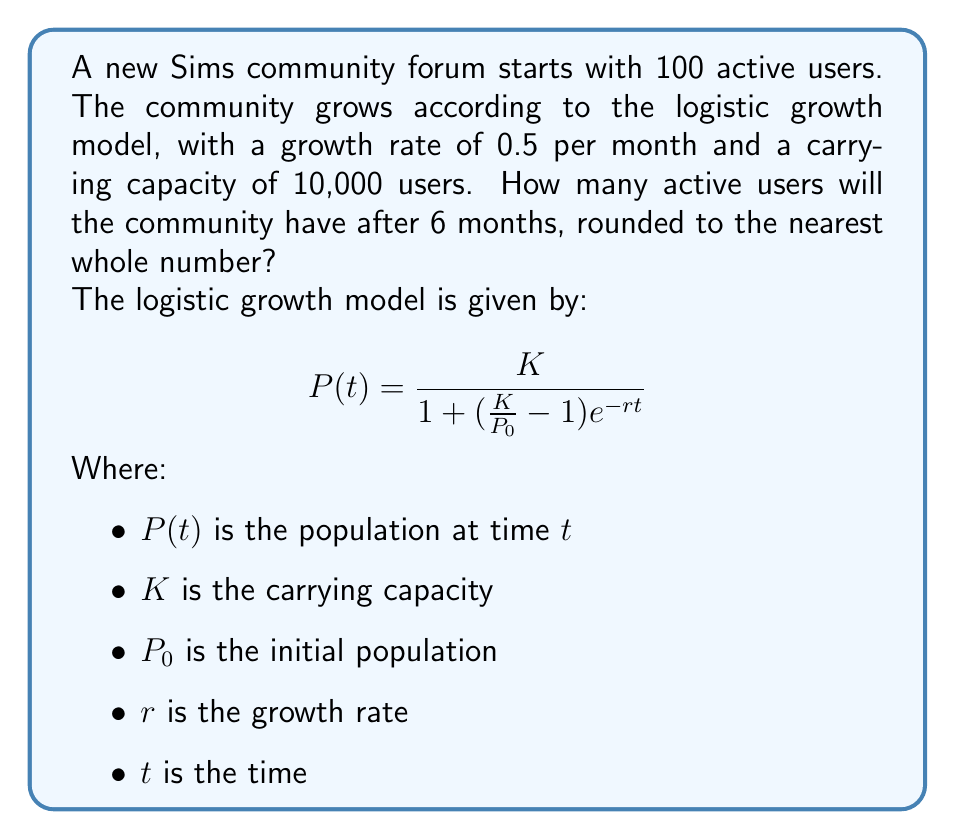Show me your answer to this math problem. To solve this problem, we'll use the logistic growth model equation and plug in the given values:

1. $K = 10,000$ (carrying capacity)
2. $P_0 = 100$ (initial population)
3. $r = 0.5$ (growth rate per month)
4. $t = 6$ (time in months)

Let's substitute these values into the equation:

$$P(6) = \frac{10000}{1 + (\frac{10000}{100} - 1)e^{-0.5 \cdot 6}}$$

Now, let's solve step by step:

1. Simplify the fraction inside the parentheses:
   $$P(6) = \frac{10000}{1 + (100 - 1)e^{-3}}$$

2. Simplify further:
   $$P(6) = \frac{10000}{1 + 99e^{-3}}$$

3. Calculate $e^{-3}$:
   $e^{-3} \approx 0.0498$

4. Multiply:
   $$P(6) = \frac{10000}{1 + 99 \cdot 0.0498} \approx \frac{10000}{5.9302}$$

5. Divide:
   $$P(6) \approx 1686.4674$$

6. Round to the nearest whole number:
   $$P(6) \approx 1686$$

Therefore, after 6 months, the Sims community forum will have approximately 1,686 active users.
Answer: 1,686 users 